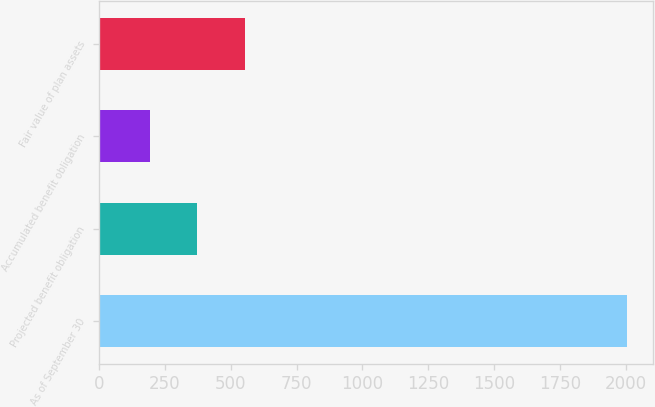Convert chart to OTSL. <chart><loc_0><loc_0><loc_500><loc_500><bar_chart><fcel>As of September 30<fcel>Projected benefit obligation<fcel>Accumulated benefit obligation<fcel>Fair value of plan assets<nl><fcel>2005<fcel>373.3<fcel>192<fcel>554.6<nl></chart> 